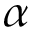Convert formula to latex. <formula><loc_0><loc_0><loc_500><loc_500>\alpha</formula> 